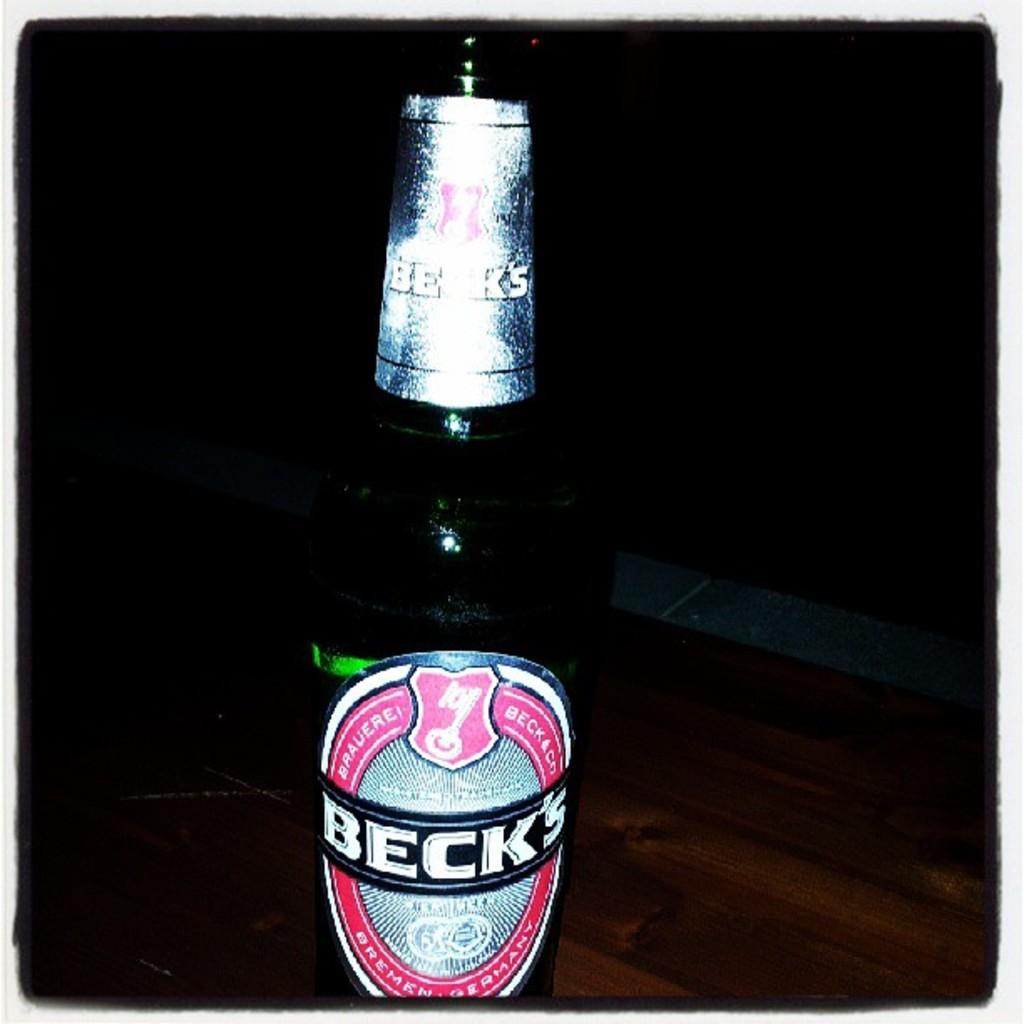<image>
Provide a brief description of the given image. A bottle of Beck's sits on a table in the dark. 